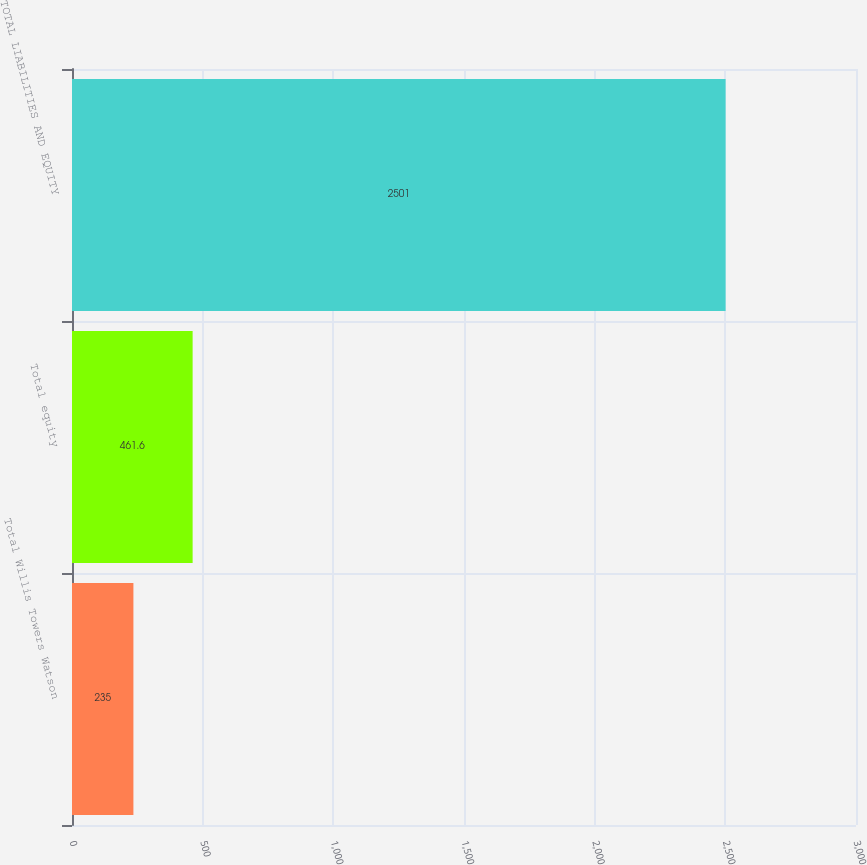<chart> <loc_0><loc_0><loc_500><loc_500><bar_chart><fcel>Total Willis Towers Watson<fcel>Total equity<fcel>TOTAL LIABILITIES AND EQUITY<nl><fcel>235<fcel>461.6<fcel>2501<nl></chart> 